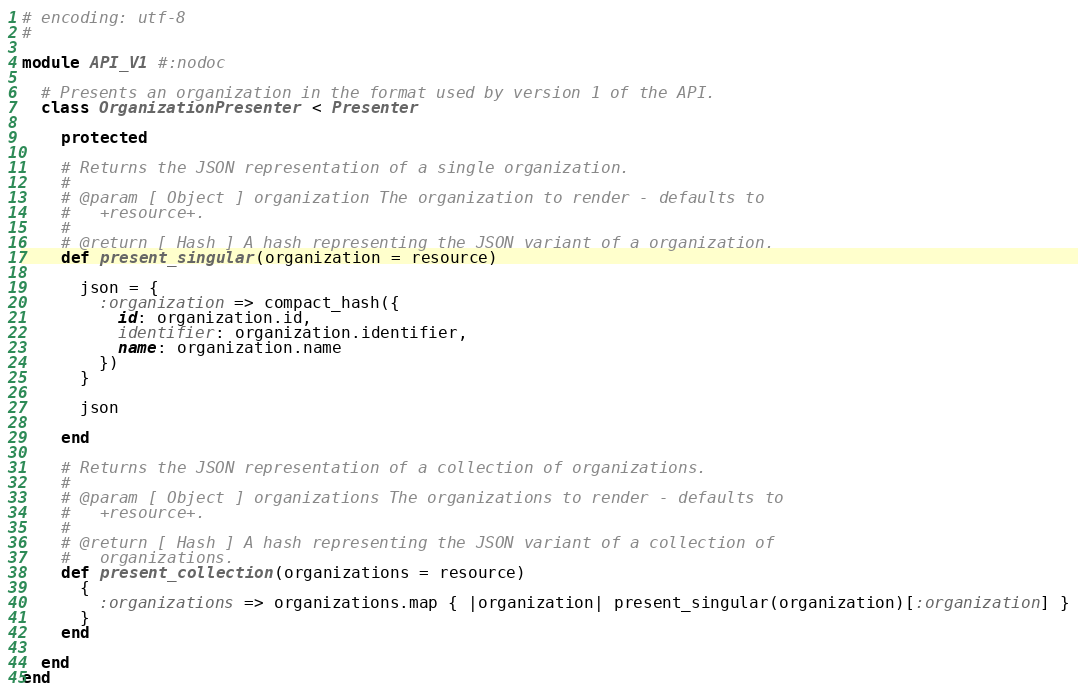Convert code to text. <code><loc_0><loc_0><loc_500><loc_500><_Ruby_># encoding: utf-8
#

module API_V1 #:nodoc

  # Presents an organization in the format used by version 1 of the API.
  class OrganizationPresenter < Presenter

    protected

    # Returns the JSON representation of a single organization.
    #
    # @param [ Object ] organization The organization to render - defaults to
    #   +resource+.
    #
    # @return [ Hash ] A hash representing the JSON variant of a organization.
    def present_singular(organization = resource)

      json = {
        :organization => compact_hash({
          id: organization.id,
          identifier: organization.identifier,
          name: organization.name
        })
      }

      json

    end

    # Returns the JSON representation of a collection of organizations.
    #
    # @param [ Object ] organizations The organizations to render - defaults to
    #   +resource+.
    #
    # @return [ Hash ] A hash representing the JSON variant of a collection of
    #   organizations.
    def present_collection(organizations = resource)
      {
        :organizations => organizations.map { |organization| present_singular(organization)[:organization] }
      }
    end

  end
end
</code> 